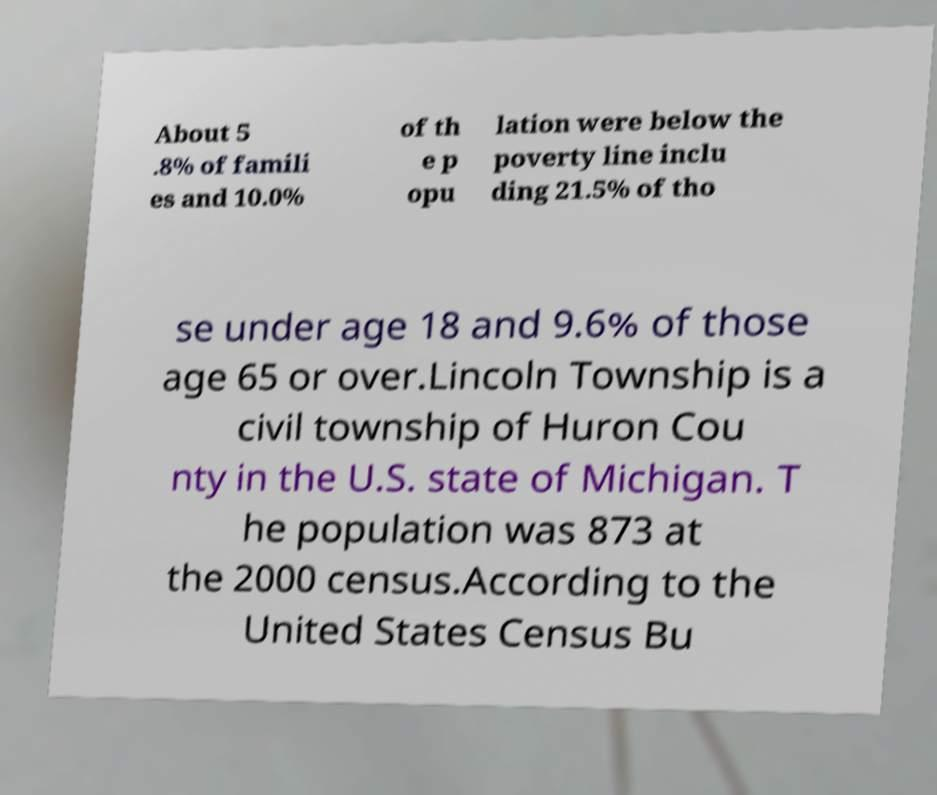Please identify and transcribe the text found in this image. About 5 .8% of famili es and 10.0% of th e p opu lation were below the poverty line inclu ding 21.5% of tho se under age 18 and 9.6% of those age 65 or over.Lincoln Township is a civil township of Huron Cou nty in the U.S. state of Michigan. T he population was 873 at the 2000 census.According to the United States Census Bu 